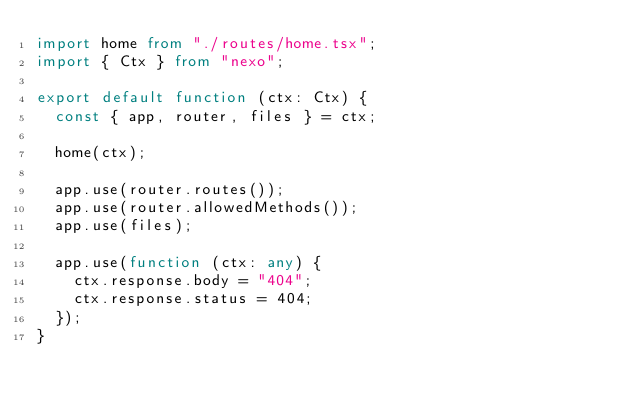<code> <loc_0><loc_0><loc_500><loc_500><_TypeScript_>import home from "./routes/home.tsx";
import { Ctx } from "nexo";

export default function (ctx: Ctx) {
  const { app, router, files } = ctx;

  home(ctx);

  app.use(router.routes());
  app.use(router.allowedMethods());
  app.use(files);

  app.use(function (ctx: any) {
    ctx.response.body = "404";
    ctx.response.status = 404;
  });
}
</code> 